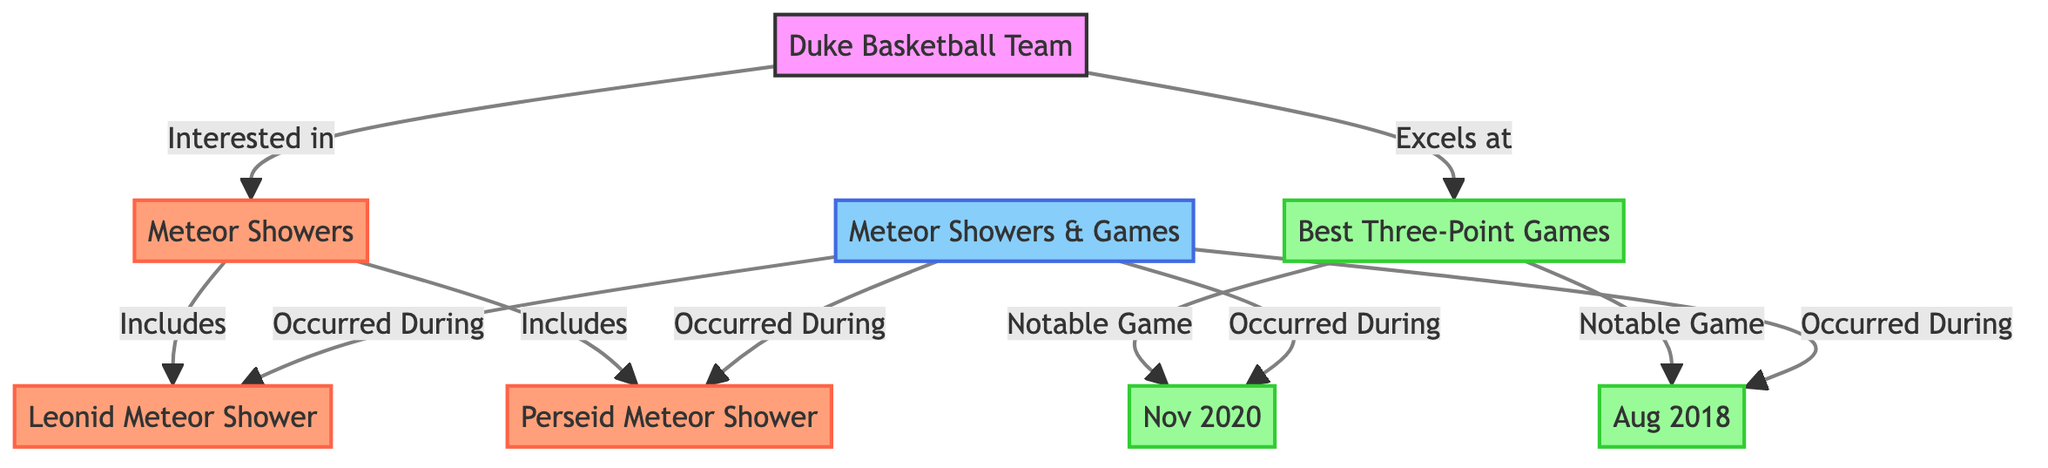What's the main focus of the diagram? The diagram visually presents the relationship between Duke Basketball's three-point games and meteor showers, highlighting notable correlations.
Answer: Shooting Stars and Three-Point Shots How many notable three-point games are mentioned? The diagram lists two specific notable three-point games: Nov 2020 and Aug 2018. By counting these nodes, we determine there are two notable games.
Answer: 2 Which meteor shower is specifically associated with the August 2018 game? The diagram indicates that the Perseid Meteor Shower is linked to the Best Three-Point Game in Aug 2018. Following the connections shows this direct relationship.
Answer: Perseid Meteor Shower What type of correlation exists between meteor showers and three-point games? The diagram explicitly identifies a correlation between occurrences of basketball games and meteor showers, implying an interest in observed timing.
Answer: Occurred During Which meteor shower occurs during the notable game in November 2020? By examining the connections, the diagram shows that the Leonid Meteor Shower occurred during the notable game in Nov 2020, establishing this link.
Answer: Leonid Meteor Shower How does the Duke Basketball Team feel about meteor showers? The diagram indicates an "Interested in" relationship, signifying that the Duke Basketball Team has a positive interest regarding meteor showers.
Answer: Interested in What color represents meteor activities in the diagram? The diagram employs a specific color for meteor activity nodes, which is light coral (#FFA07A) according to the color coding defined in the code.
Answer: Light Coral Which class of nodes represents the Duke Basketball Team's three-point achievements? The nodes representing the best three-point games are classified with a distinct light green color (#98FB98), marking them clearly in the diagram.
Answer: Light Green What does the diagram suggest about the timing of events? The diagram shows that both the meteor showers and notable games occurred during the same timeframes, suggesting a chronological relationship.
Answer: Temporal Relationship 